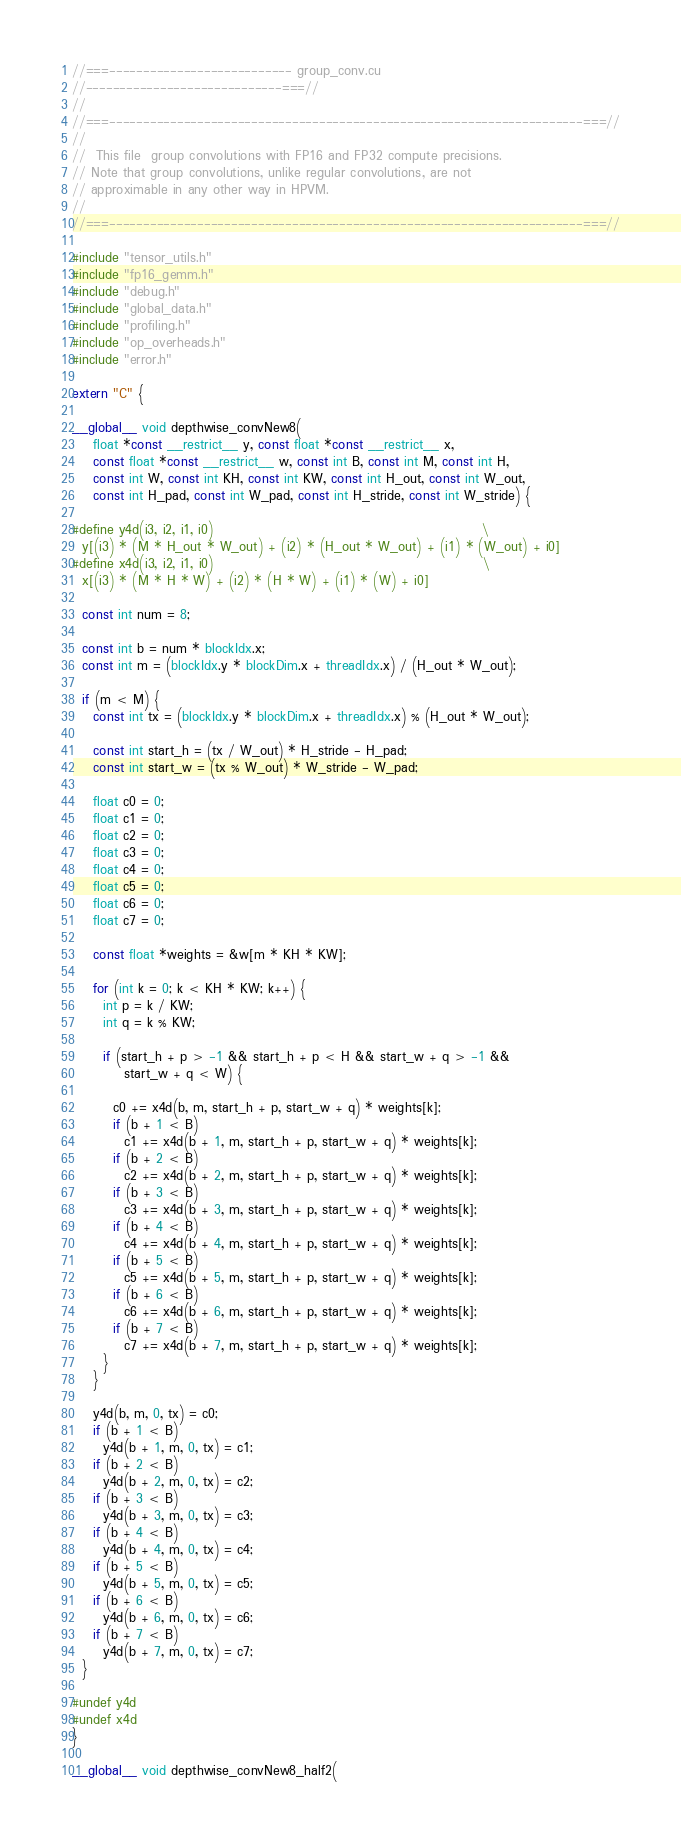<code> <loc_0><loc_0><loc_500><loc_500><_Cuda_>//===--------------------------- group_conv.cu
//-----------------------------===//
//
//===----------------------------------------------------------------------===//
//
//  This file  group convolutions with FP16 and FP32 compute precisions.
// Note that group convolutions, unlike regular convolutions, are not
// approximable in any other way in HPVM.
//
//===----------------------------------------------------------------------===//

#include "tensor_utils.h"
#include "fp16_gemm.h"
#include "debug.h"
#include "global_data.h"
#include "profiling.h"
#include "op_overheads.h"
#include "error.h"

extern "C" {

__global__ void depthwise_convNew8(
    float *const __restrict__ y, const float *const __restrict__ x,
    const float *const __restrict__ w, const int B, const int M, const int H,
    const int W, const int KH, const int KW, const int H_out, const int W_out,
    const int H_pad, const int W_pad, const int H_stride, const int W_stride) {

#define y4d(i3, i2, i1, i0)                                                    \
  y[(i3) * (M * H_out * W_out) + (i2) * (H_out * W_out) + (i1) * (W_out) + i0]
#define x4d(i3, i2, i1, i0)                                                    \
  x[(i3) * (M * H * W) + (i2) * (H * W) + (i1) * (W) + i0]

  const int num = 8;

  const int b = num * blockIdx.x;
  const int m = (blockIdx.y * blockDim.x + threadIdx.x) / (H_out * W_out);

  if (m < M) {
    const int tx = (blockIdx.y * blockDim.x + threadIdx.x) % (H_out * W_out);

    const int start_h = (tx / W_out) * H_stride - H_pad;
    const int start_w = (tx % W_out) * W_stride - W_pad;

    float c0 = 0;
    float c1 = 0;
    float c2 = 0;
    float c3 = 0;
    float c4 = 0;
    float c5 = 0;
    float c6 = 0;
    float c7 = 0;

    const float *weights = &w[m * KH * KW];

    for (int k = 0; k < KH * KW; k++) {
      int p = k / KW;
      int q = k % KW;

      if (start_h + p > -1 && start_h + p < H && start_w + q > -1 &&
          start_w + q < W) {

        c0 += x4d(b, m, start_h + p, start_w + q) * weights[k];
        if (b + 1 < B)
          c1 += x4d(b + 1, m, start_h + p, start_w + q) * weights[k];
        if (b + 2 < B)
          c2 += x4d(b + 2, m, start_h + p, start_w + q) * weights[k];
        if (b + 3 < B)
          c3 += x4d(b + 3, m, start_h + p, start_w + q) * weights[k];
        if (b + 4 < B)
          c4 += x4d(b + 4, m, start_h + p, start_w + q) * weights[k];
        if (b + 5 < B)
          c5 += x4d(b + 5, m, start_h + p, start_w + q) * weights[k];
        if (b + 6 < B)
          c6 += x4d(b + 6, m, start_h + p, start_w + q) * weights[k];
        if (b + 7 < B)
          c7 += x4d(b + 7, m, start_h + p, start_w + q) * weights[k];
      }
    }

    y4d(b, m, 0, tx) = c0;
    if (b + 1 < B)
      y4d(b + 1, m, 0, tx) = c1;
    if (b + 2 < B)
      y4d(b + 2, m, 0, tx) = c2;
    if (b + 3 < B)
      y4d(b + 3, m, 0, tx) = c3;
    if (b + 4 < B)
      y4d(b + 4, m, 0, tx) = c4;
    if (b + 5 < B)
      y4d(b + 5, m, 0, tx) = c5;
    if (b + 6 < B)
      y4d(b + 6, m, 0, tx) = c6;
    if (b + 7 < B)
      y4d(b + 7, m, 0, tx) = c7;
  }

#undef y4d
#undef x4d
}

__global__ void depthwise_convNew8_half2(</code> 